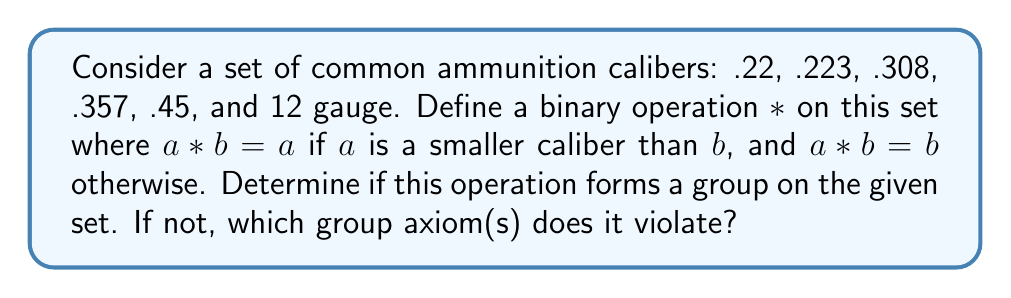Could you help me with this problem? To determine if this operation forms a group, we need to check the four group axioms: closure, associativity, identity, and inverse.

1. Closure: 
The operation is defined for all pairs of elements in the set, so closure is satisfied.

2. Associativity:
Let's check if (a * b) * c = a * (b * c) for all a, b, c in the set.
Consider (.22 * .308) * .45 = .22 * .45 = .22
But .22 * (.308 * .45) = .22 * .45 = .22
This property holds for all combinations, so associativity is satisfied.

3. Identity:
The identity element should be e such that a * e = e * a = a for all a in the set.
In this case, 12 gauge acts as the identity since it's the largest caliber:
a * 12 gauge = a and 12 gauge * a = a for all a in the set.

4. Inverse:
For each element a, there should exist an element b such that a * b = b * a = e (identity).
However, for .22, there is no element b such that .22 * b = 12 gauge (the identity).
This violates the inverse axiom.

Since the inverse axiom is violated, this operation does not form a group on the given set.
Answer: The operation does not form a group. It violates the inverse axiom. 